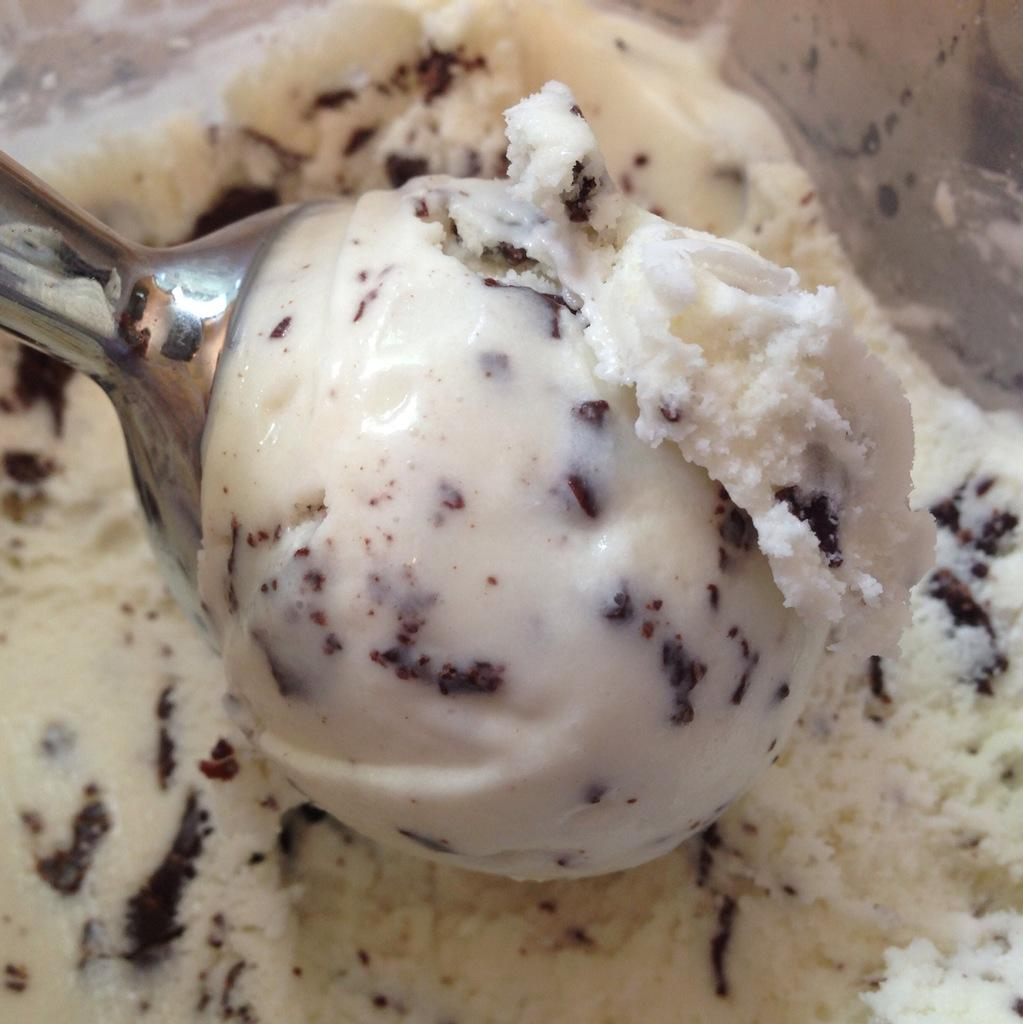What is the main subject of the image? There is a scoop of ice cream in the image. Can you describe the ice cream in more detail? The ice cream has chocolate in it. Is there any other ice cream visible in the image? Yes, there is more ice cream visible in the backdrop. How many crayons are used to draw the ice cream in the image? There are no crayons present in the image, as it is a photograph of actual ice cream. 